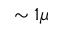<formula> <loc_0><loc_0><loc_500><loc_500>\sim 1 \mu</formula> 